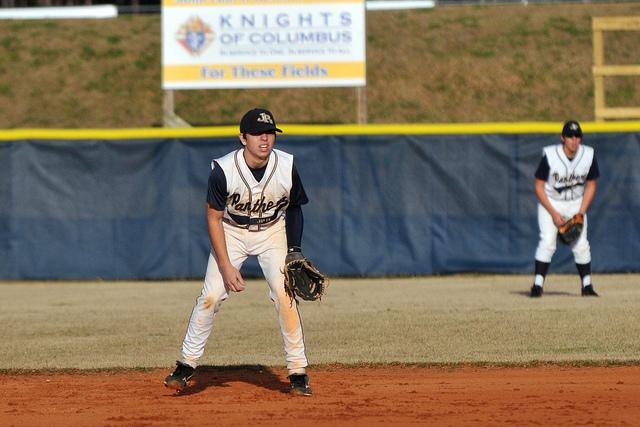What colors are the player's uniform?
Be succinct. Black and white. What is the name of the team?
Quick response, please. Panthers. Is the player in the forefront of the image left or right handed?
Write a very short answer. Right. What position is the man farthermost in the back playing?
Be succinct. Outfield. 